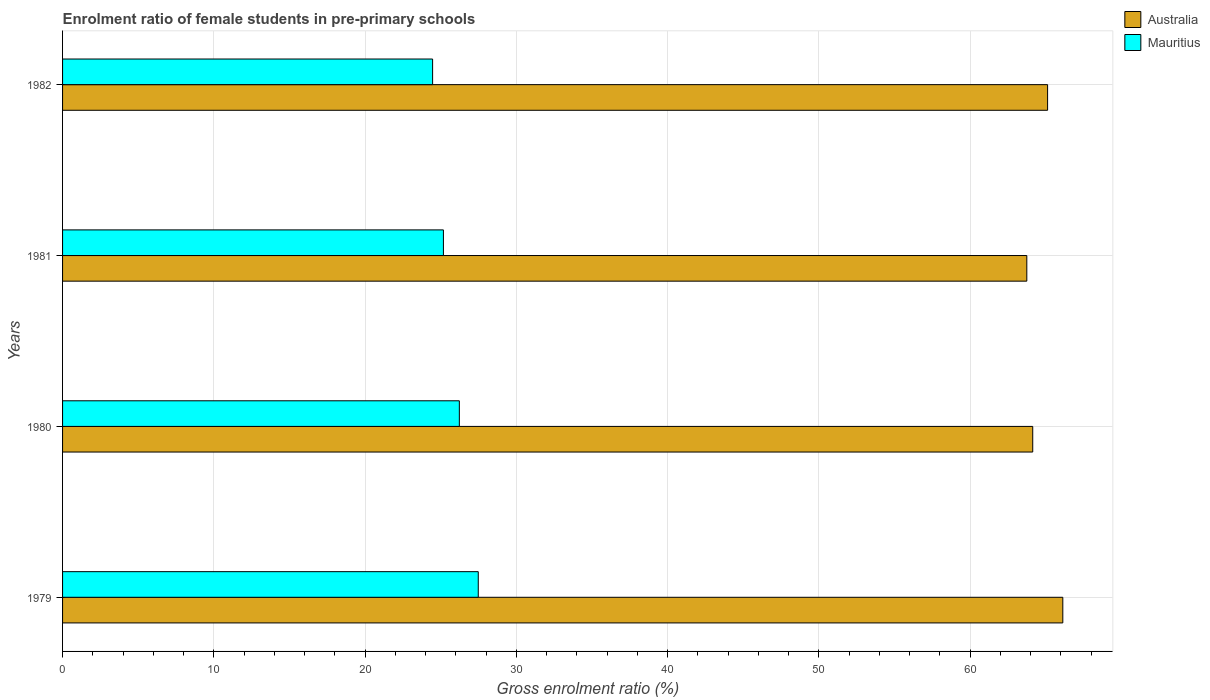How many bars are there on the 4th tick from the top?
Offer a terse response. 2. How many bars are there on the 3rd tick from the bottom?
Provide a short and direct response. 2. What is the label of the 2nd group of bars from the top?
Ensure brevity in your answer.  1981. In how many cases, is the number of bars for a given year not equal to the number of legend labels?
Keep it short and to the point. 0. What is the enrolment ratio of female students in pre-primary schools in Australia in 1981?
Offer a terse response. 63.74. Across all years, what is the maximum enrolment ratio of female students in pre-primary schools in Australia?
Keep it short and to the point. 66.12. Across all years, what is the minimum enrolment ratio of female students in pre-primary schools in Mauritius?
Offer a very short reply. 24.46. In which year was the enrolment ratio of female students in pre-primary schools in Mauritius maximum?
Your answer should be very brief. 1979. What is the total enrolment ratio of female students in pre-primary schools in Australia in the graph?
Give a very brief answer. 259.12. What is the difference between the enrolment ratio of female students in pre-primary schools in Mauritius in 1979 and that in 1981?
Your answer should be very brief. 2.3. What is the difference between the enrolment ratio of female students in pre-primary schools in Mauritius in 1981 and the enrolment ratio of female students in pre-primary schools in Australia in 1980?
Keep it short and to the point. -38.96. What is the average enrolment ratio of female students in pre-primary schools in Mauritius per year?
Make the answer very short. 25.84. In the year 1982, what is the difference between the enrolment ratio of female students in pre-primary schools in Mauritius and enrolment ratio of female students in pre-primary schools in Australia?
Offer a very short reply. -40.66. In how many years, is the enrolment ratio of female students in pre-primary schools in Mauritius greater than 56 %?
Provide a short and direct response. 0. What is the ratio of the enrolment ratio of female students in pre-primary schools in Australia in 1979 to that in 1982?
Ensure brevity in your answer.  1.02. Is the difference between the enrolment ratio of female students in pre-primary schools in Mauritius in 1979 and 1982 greater than the difference between the enrolment ratio of female students in pre-primary schools in Australia in 1979 and 1982?
Your answer should be very brief. Yes. What is the difference between the highest and the second highest enrolment ratio of female students in pre-primary schools in Australia?
Keep it short and to the point. 1.01. What is the difference between the highest and the lowest enrolment ratio of female students in pre-primary schools in Mauritius?
Keep it short and to the point. 3.02. In how many years, is the enrolment ratio of female students in pre-primary schools in Australia greater than the average enrolment ratio of female students in pre-primary schools in Australia taken over all years?
Your answer should be compact. 2. What does the 1st bar from the top in 1981 represents?
Offer a terse response. Mauritius. Are all the bars in the graph horizontal?
Provide a succinct answer. Yes. Does the graph contain any zero values?
Your answer should be compact. No. Where does the legend appear in the graph?
Provide a short and direct response. Top right. What is the title of the graph?
Give a very brief answer. Enrolment ratio of female students in pre-primary schools. What is the label or title of the Y-axis?
Offer a terse response. Years. What is the Gross enrolment ratio (%) of Australia in 1979?
Provide a succinct answer. 66.12. What is the Gross enrolment ratio (%) in Mauritius in 1979?
Ensure brevity in your answer.  27.48. What is the Gross enrolment ratio (%) of Australia in 1980?
Your response must be concise. 64.14. What is the Gross enrolment ratio (%) in Mauritius in 1980?
Provide a succinct answer. 26.23. What is the Gross enrolment ratio (%) in Australia in 1981?
Offer a very short reply. 63.74. What is the Gross enrolment ratio (%) in Mauritius in 1981?
Ensure brevity in your answer.  25.18. What is the Gross enrolment ratio (%) of Australia in 1982?
Offer a terse response. 65.12. What is the Gross enrolment ratio (%) in Mauritius in 1982?
Your response must be concise. 24.46. Across all years, what is the maximum Gross enrolment ratio (%) of Australia?
Keep it short and to the point. 66.12. Across all years, what is the maximum Gross enrolment ratio (%) of Mauritius?
Ensure brevity in your answer.  27.48. Across all years, what is the minimum Gross enrolment ratio (%) in Australia?
Provide a succinct answer. 63.74. Across all years, what is the minimum Gross enrolment ratio (%) in Mauritius?
Give a very brief answer. 24.46. What is the total Gross enrolment ratio (%) in Australia in the graph?
Your response must be concise. 259.12. What is the total Gross enrolment ratio (%) in Mauritius in the graph?
Give a very brief answer. 103.35. What is the difference between the Gross enrolment ratio (%) of Australia in 1979 and that in 1980?
Your response must be concise. 1.99. What is the difference between the Gross enrolment ratio (%) in Mauritius in 1979 and that in 1980?
Your response must be concise. 1.25. What is the difference between the Gross enrolment ratio (%) of Australia in 1979 and that in 1981?
Your response must be concise. 2.38. What is the difference between the Gross enrolment ratio (%) of Mauritius in 1979 and that in 1981?
Your answer should be compact. 2.3. What is the difference between the Gross enrolment ratio (%) in Australia in 1979 and that in 1982?
Provide a short and direct response. 1.01. What is the difference between the Gross enrolment ratio (%) of Mauritius in 1979 and that in 1982?
Your response must be concise. 3.02. What is the difference between the Gross enrolment ratio (%) in Australia in 1980 and that in 1981?
Provide a succinct answer. 0.39. What is the difference between the Gross enrolment ratio (%) of Mauritius in 1980 and that in 1981?
Your answer should be very brief. 1.05. What is the difference between the Gross enrolment ratio (%) of Australia in 1980 and that in 1982?
Keep it short and to the point. -0.98. What is the difference between the Gross enrolment ratio (%) of Mauritius in 1980 and that in 1982?
Your response must be concise. 1.77. What is the difference between the Gross enrolment ratio (%) in Australia in 1981 and that in 1982?
Your response must be concise. -1.37. What is the difference between the Gross enrolment ratio (%) in Mauritius in 1981 and that in 1982?
Your answer should be very brief. 0.71. What is the difference between the Gross enrolment ratio (%) in Australia in 1979 and the Gross enrolment ratio (%) in Mauritius in 1980?
Your answer should be very brief. 39.89. What is the difference between the Gross enrolment ratio (%) of Australia in 1979 and the Gross enrolment ratio (%) of Mauritius in 1981?
Give a very brief answer. 40.95. What is the difference between the Gross enrolment ratio (%) of Australia in 1979 and the Gross enrolment ratio (%) of Mauritius in 1982?
Offer a very short reply. 41.66. What is the difference between the Gross enrolment ratio (%) in Australia in 1980 and the Gross enrolment ratio (%) in Mauritius in 1981?
Your answer should be compact. 38.96. What is the difference between the Gross enrolment ratio (%) in Australia in 1980 and the Gross enrolment ratio (%) in Mauritius in 1982?
Offer a very short reply. 39.67. What is the difference between the Gross enrolment ratio (%) of Australia in 1981 and the Gross enrolment ratio (%) of Mauritius in 1982?
Provide a short and direct response. 39.28. What is the average Gross enrolment ratio (%) in Australia per year?
Your response must be concise. 64.78. What is the average Gross enrolment ratio (%) of Mauritius per year?
Keep it short and to the point. 25.84. In the year 1979, what is the difference between the Gross enrolment ratio (%) in Australia and Gross enrolment ratio (%) in Mauritius?
Offer a very short reply. 38.64. In the year 1980, what is the difference between the Gross enrolment ratio (%) of Australia and Gross enrolment ratio (%) of Mauritius?
Offer a very short reply. 37.91. In the year 1981, what is the difference between the Gross enrolment ratio (%) of Australia and Gross enrolment ratio (%) of Mauritius?
Provide a succinct answer. 38.57. In the year 1982, what is the difference between the Gross enrolment ratio (%) in Australia and Gross enrolment ratio (%) in Mauritius?
Your answer should be very brief. 40.66. What is the ratio of the Gross enrolment ratio (%) of Australia in 1979 to that in 1980?
Your answer should be very brief. 1.03. What is the ratio of the Gross enrolment ratio (%) in Mauritius in 1979 to that in 1980?
Provide a short and direct response. 1.05. What is the ratio of the Gross enrolment ratio (%) of Australia in 1979 to that in 1981?
Provide a succinct answer. 1.04. What is the ratio of the Gross enrolment ratio (%) of Mauritius in 1979 to that in 1981?
Provide a short and direct response. 1.09. What is the ratio of the Gross enrolment ratio (%) in Australia in 1979 to that in 1982?
Provide a succinct answer. 1.02. What is the ratio of the Gross enrolment ratio (%) of Mauritius in 1979 to that in 1982?
Provide a short and direct response. 1.12. What is the ratio of the Gross enrolment ratio (%) in Australia in 1980 to that in 1981?
Make the answer very short. 1.01. What is the ratio of the Gross enrolment ratio (%) in Mauritius in 1980 to that in 1981?
Your answer should be very brief. 1.04. What is the ratio of the Gross enrolment ratio (%) in Australia in 1980 to that in 1982?
Keep it short and to the point. 0.98. What is the ratio of the Gross enrolment ratio (%) of Mauritius in 1980 to that in 1982?
Make the answer very short. 1.07. What is the ratio of the Gross enrolment ratio (%) in Australia in 1981 to that in 1982?
Your answer should be compact. 0.98. What is the ratio of the Gross enrolment ratio (%) in Mauritius in 1981 to that in 1982?
Offer a terse response. 1.03. What is the difference between the highest and the second highest Gross enrolment ratio (%) in Australia?
Give a very brief answer. 1.01. What is the difference between the highest and the second highest Gross enrolment ratio (%) of Mauritius?
Keep it short and to the point. 1.25. What is the difference between the highest and the lowest Gross enrolment ratio (%) of Australia?
Provide a succinct answer. 2.38. What is the difference between the highest and the lowest Gross enrolment ratio (%) in Mauritius?
Provide a short and direct response. 3.02. 